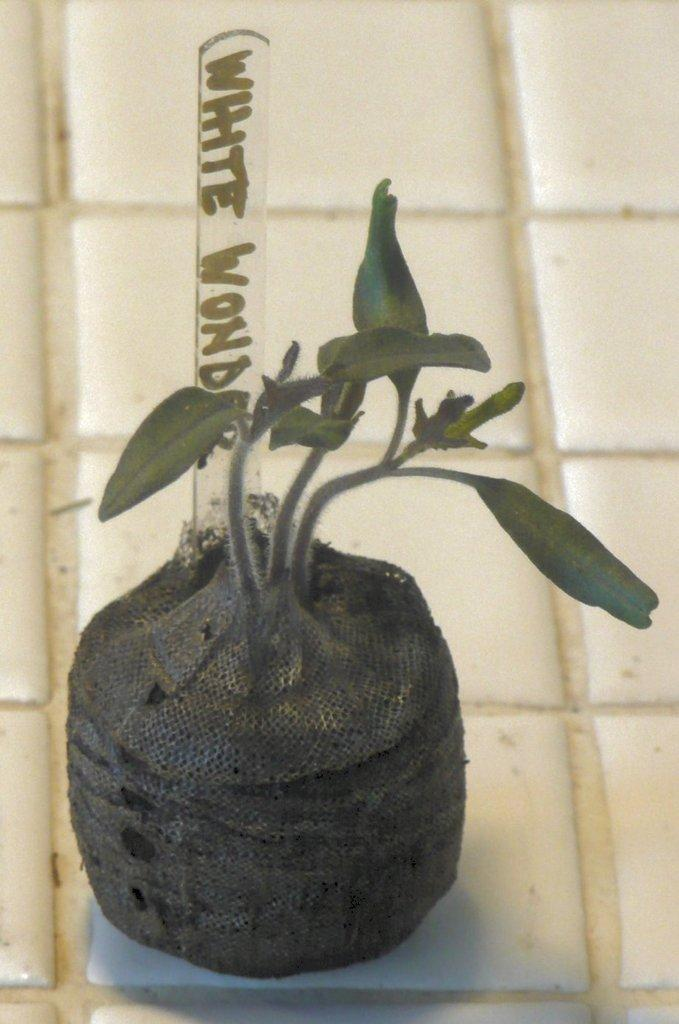What type of living organism can be seen in the image? There is a plant in the image. How can the plant be identified in the image? The plant has a name board in the image. Where is the plant and name board located in the image? The plant and name board are placed on the floor. What type of oil can be seen dripping from the plant in the image? There is no oil present in the image; it features a plant with a name board on the floor. 